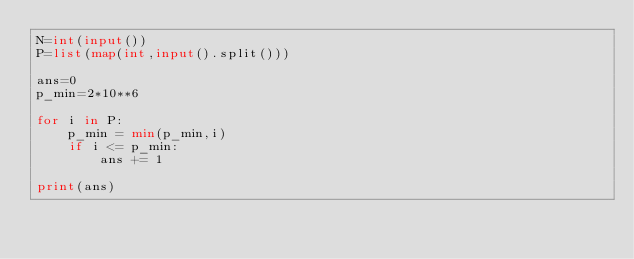<code> <loc_0><loc_0><loc_500><loc_500><_Python_>N=int(input())
P=list(map(int,input().split()))

ans=0
p_min=2*10**6

for i in P:
    p_min = min(p_min,i)
    if i <= p_min:
        ans += 1

print(ans)
</code> 